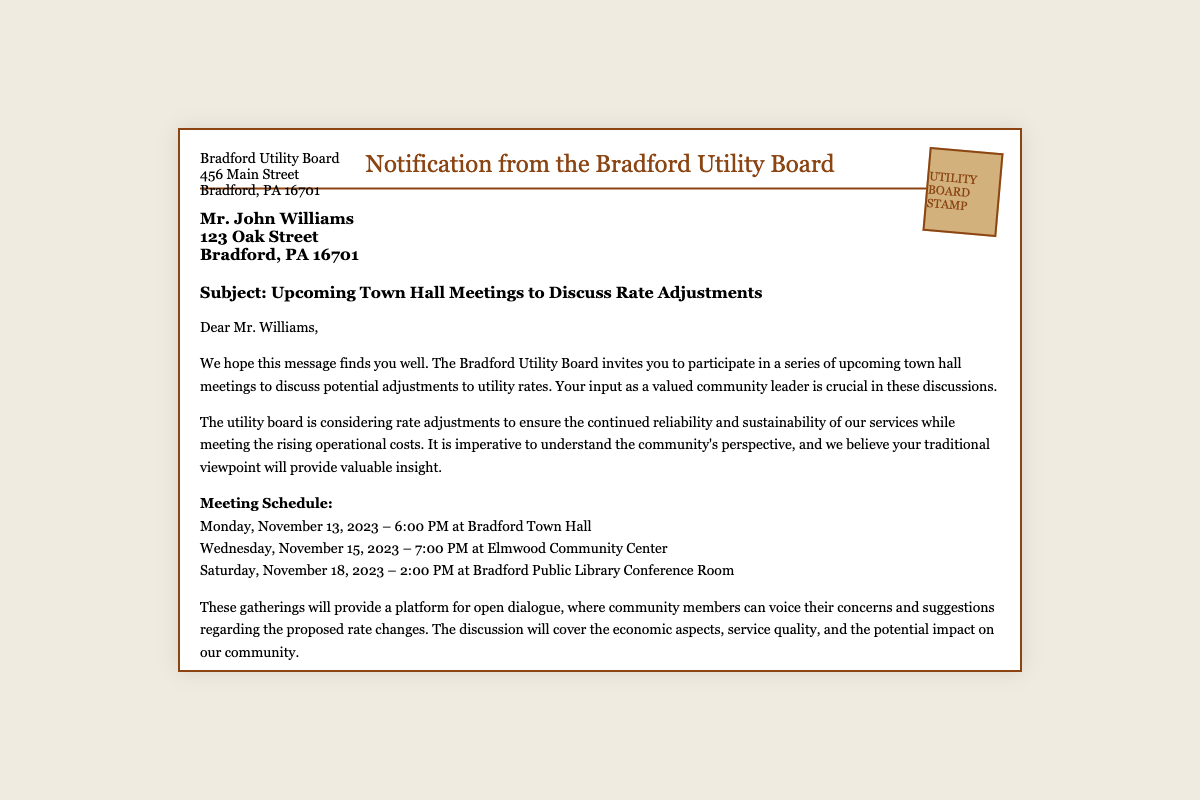What is the sender's name? The sender's name is mentioned at the top of the document as "Bradford Utility Board."
Answer: Bradford Utility Board What is the date of the first meeting? The first meeting is scheduled for Monday, November 13, 2023.
Answer: November 13, 2023 Where will the second meeting take place? The document specifies that the second meeting will be at "Elmwood Community Center."
Answer: Elmwood Community Center What is the purpose of the town hall meetings? The document states that the meetings are to discuss potential adjustments to utility rates.
Answer: Potential adjustments to utility rates What is the contact email provided? The email for inquiries is listed in the signature section as "info@bradfordutilities.org."
Answer: info@bradfordutilities.org How many meetings are scheduled? The document lists three separate meetings that will take place.
Answer: Three What is the significance of Mr. John Williams' perspective? The utility board believes Mr. Williams' traditional viewpoint will provide valuable insight.
Answer: Valuable insight What is the phone number for the Bradford Utility Board? The phone number is provided in the signature section as "(814) 555-1234."
Answer: (814) 555-1234 What time does the last meeting start? The last meeting is scheduled to start at 2:00 PM.
Answer: 2:00 PM 